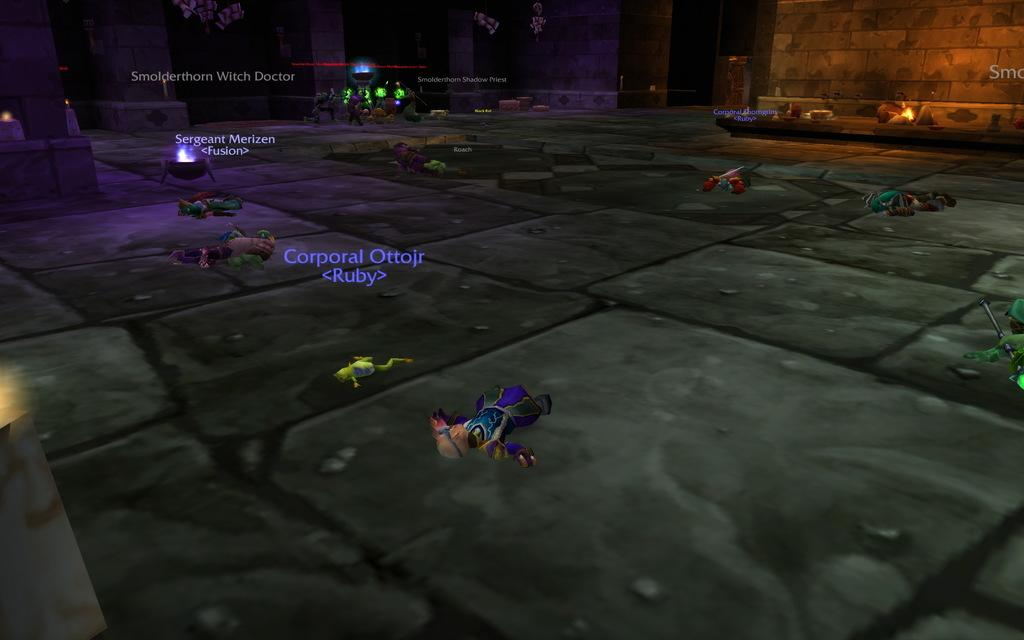What type of image is being described? The image is animated. What kind of characters can be seen in the animated image? There are animations of human beings in the image. What is the setting of the image? The image has a floor and a wall. Are there any written elements in the image? Yes, there are different texts present in the image. What type of fruit is being held by the animated character in the image? There is no fruit present in the image; it only features animations of human beings and text. 